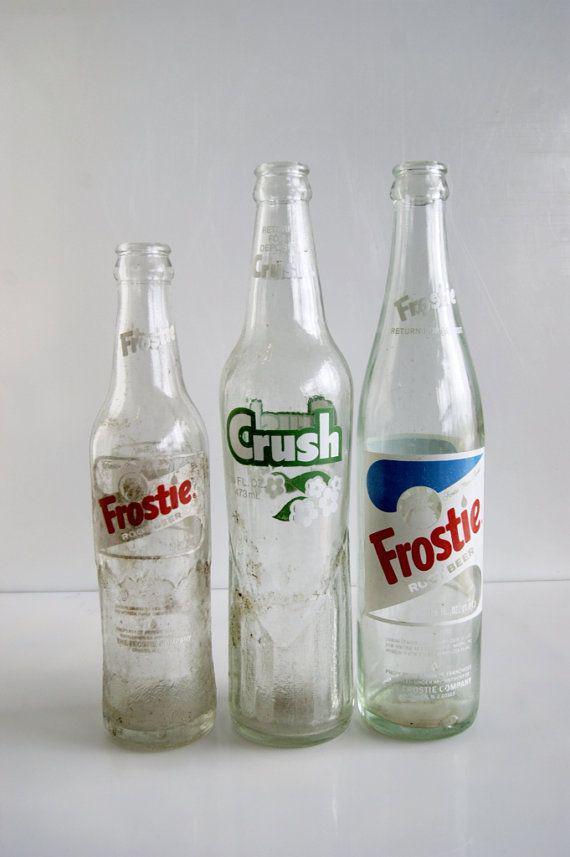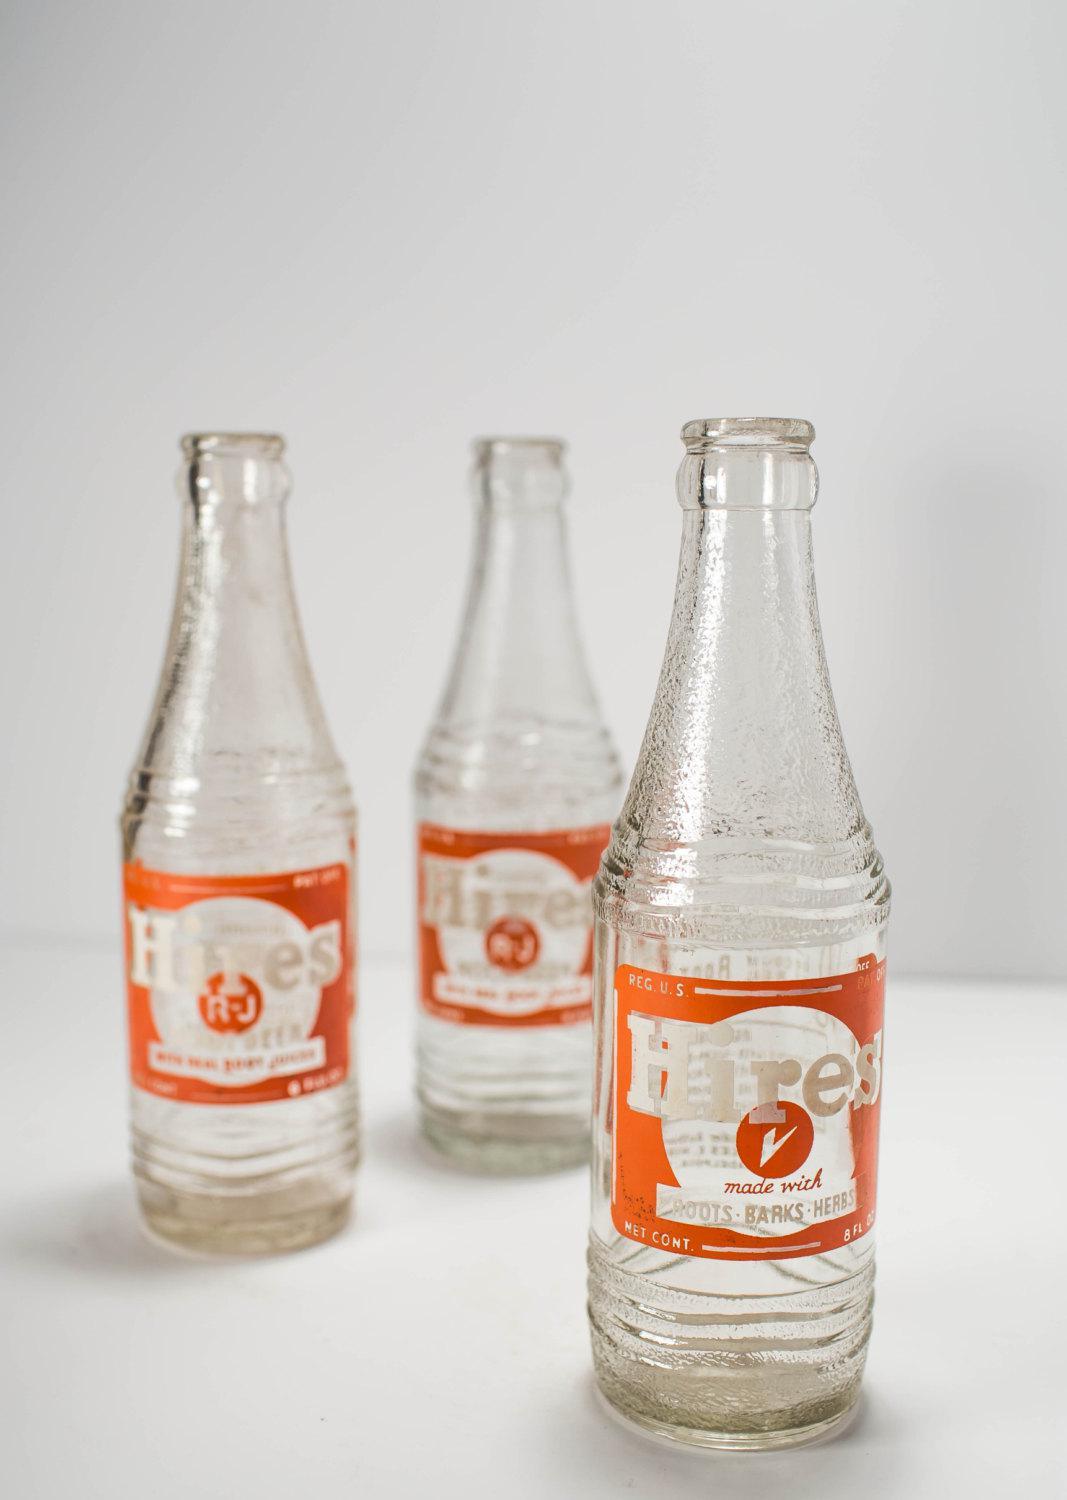The first image is the image on the left, the second image is the image on the right. Considering the images on both sides, is "Each image contains three empty glass soda bottles, and at least one image features bottles with orange labels facing forward." valid? Answer yes or no. Yes. The first image is the image on the left, the second image is the image on the right. Considering the images on both sides, is "There are fewer than six bottles in total." valid? Answer yes or no. No. 